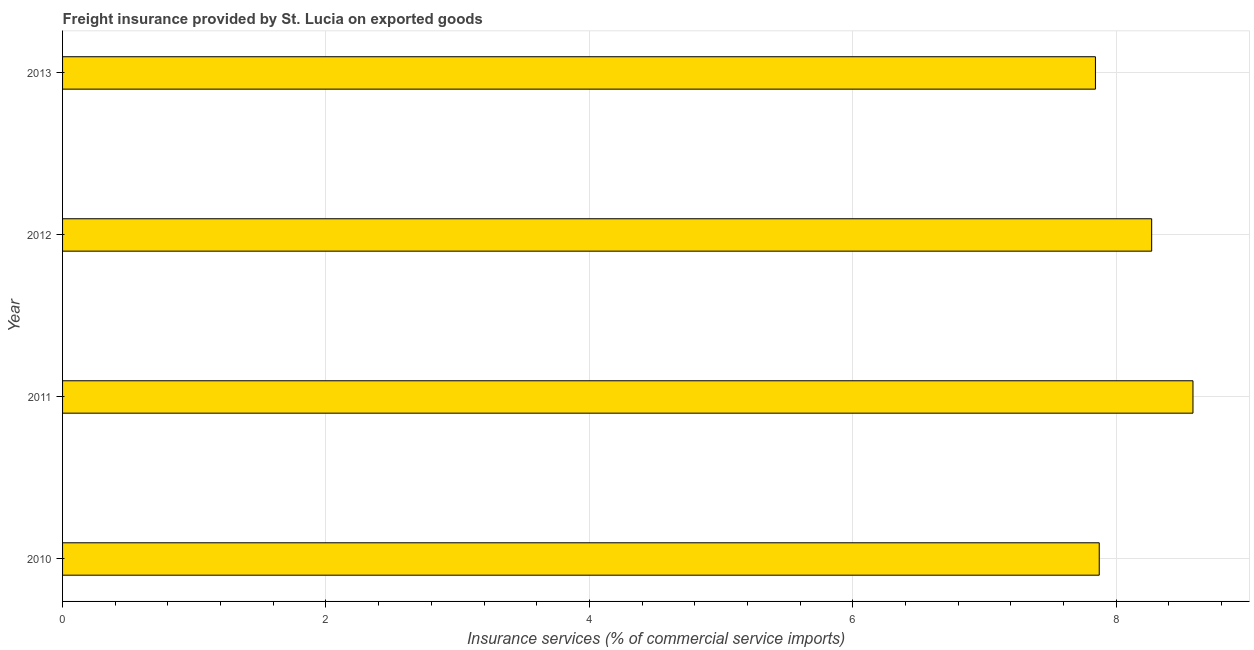Does the graph contain grids?
Your response must be concise. Yes. What is the title of the graph?
Keep it short and to the point. Freight insurance provided by St. Lucia on exported goods . What is the label or title of the X-axis?
Your answer should be very brief. Insurance services (% of commercial service imports). What is the label or title of the Y-axis?
Your answer should be compact. Year. What is the freight insurance in 2011?
Offer a terse response. 8.58. Across all years, what is the maximum freight insurance?
Make the answer very short. 8.58. Across all years, what is the minimum freight insurance?
Offer a very short reply. 7.84. What is the sum of the freight insurance?
Give a very brief answer. 32.57. What is the difference between the freight insurance in 2010 and 2011?
Offer a very short reply. -0.71. What is the average freight insurance per year?
Your answer should be compact. 8.14. What is the median freight insurance?
Offer a very short reply. 8.07. In how many years, is the freight insurance greater than 8.4 %?
Your answer should be compact. 1. What is the ratio of the freight insurance in 2011 to that in 2012?
Make the answer very short. 1.04. Is the freight insurance in 2010 less than that in 2013?
Give a very brief answer. No. What is the difference between the highest and the second highest freight insurance?
Your response must be concise. 0.31. What is the difference between the highest and the lowest freight insurance?
Provide a short and direct response. 0.74. Are all the bars in the graph horizontal?
Ensure brevity in your answer.  Yes. What is the difference between two consecutive major ticks on the X-axis?
Your answer should be very brief. 2. Are the values on the major ticks of X-axis written in scientific E-notation?
Make the answer very short. No. What is the Insurance services (% of commercial service imports) of 2010?
Your response must be concise. 7.87. What is the Insurance services (% of commercial service imports) of 2011?
Your answer should be compact. 8.58. What is the Insurance services (% of commercial service imports) in 2012?
Offer a very short reply. 8.27. What is the Insurance services (% of commercial service imports) in 2013?
Your response must be concise. 7.84. What is the difference between the Insurance services (% of commercial service imports) in 2010 and 2011?
Your response must be concise. -0.71. What is the difference between the Insurance services (% of commercial service imports) in 2010 and 2012?
Provide a succinct answer. -0.4. What is the difference between the Insurance services (% of commercial service imports) in 2010 and 2013?
Keep it short and to the point. 0.03. What is the difference between the Insurance services (% of commercial service imports) in 2011 and 2012?
Keep it short and to the point. 0.31. What is the difference between the Insurance services (% of commercial service imports) in 2011 and 2013?
Offer a very short reply. 0.74. What is the difference between the Insurance services (% of commercial service imports) in 2012 and 2013?
Provide a short and direct response. 0.43. What is the ratio of the Insurance services (% of commercial service imports) in 2010 to that in 2011?
Give a very brief answer. 0.92. What is the ratio of the Insurance services (% of commercial service imports) in 2010 to that in 2012?
Give a very brief answer. 0.95. What is the ratio of the Insurance services (% of commercial service imports) in 2010 to that in 2013?
Provide a succinct answer. 1. What is the ratio of the Insurance services (% of commercial service imports) in 2011 to that in 2012?
Provide a short and direct response. 1.04. What is the ratio of the Insurance services (% of commercial service imports) in 2011 to that in 2013?
Offer a terse response. 1.09. What is the ratio of the Insurance services (% of commercial service imports) in 2012 to that in 2013?
Offer a terse response. 1.05. 